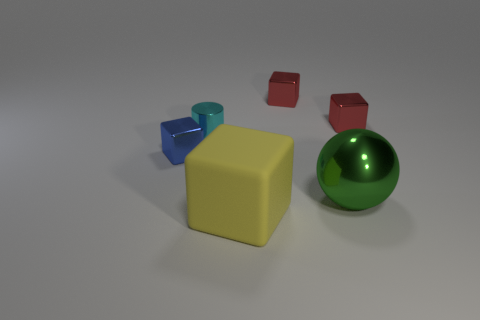Subtract 2 cubes. How many cubes are left? 2 Subtract all yellow cubes. How many cubes are left? 3 Subtract all cyan blocks. Subtract all yellow spheres. How many blocks are left? 4 Add 2 big brown shiny blocks. How many objects exist? 8 Subtract all cylinders. How many objects are left? 5 Add 1 big green spheres. How many big green spheres are left? 2 Add 2 big brown metal spheres. How many big brown metal spheres exist? 2 Subtract 0 purple balls. How many objects are left? 6 Subtract all green metallic cylinders. Subtract all tiny red cubes. How many objects are left? 4 